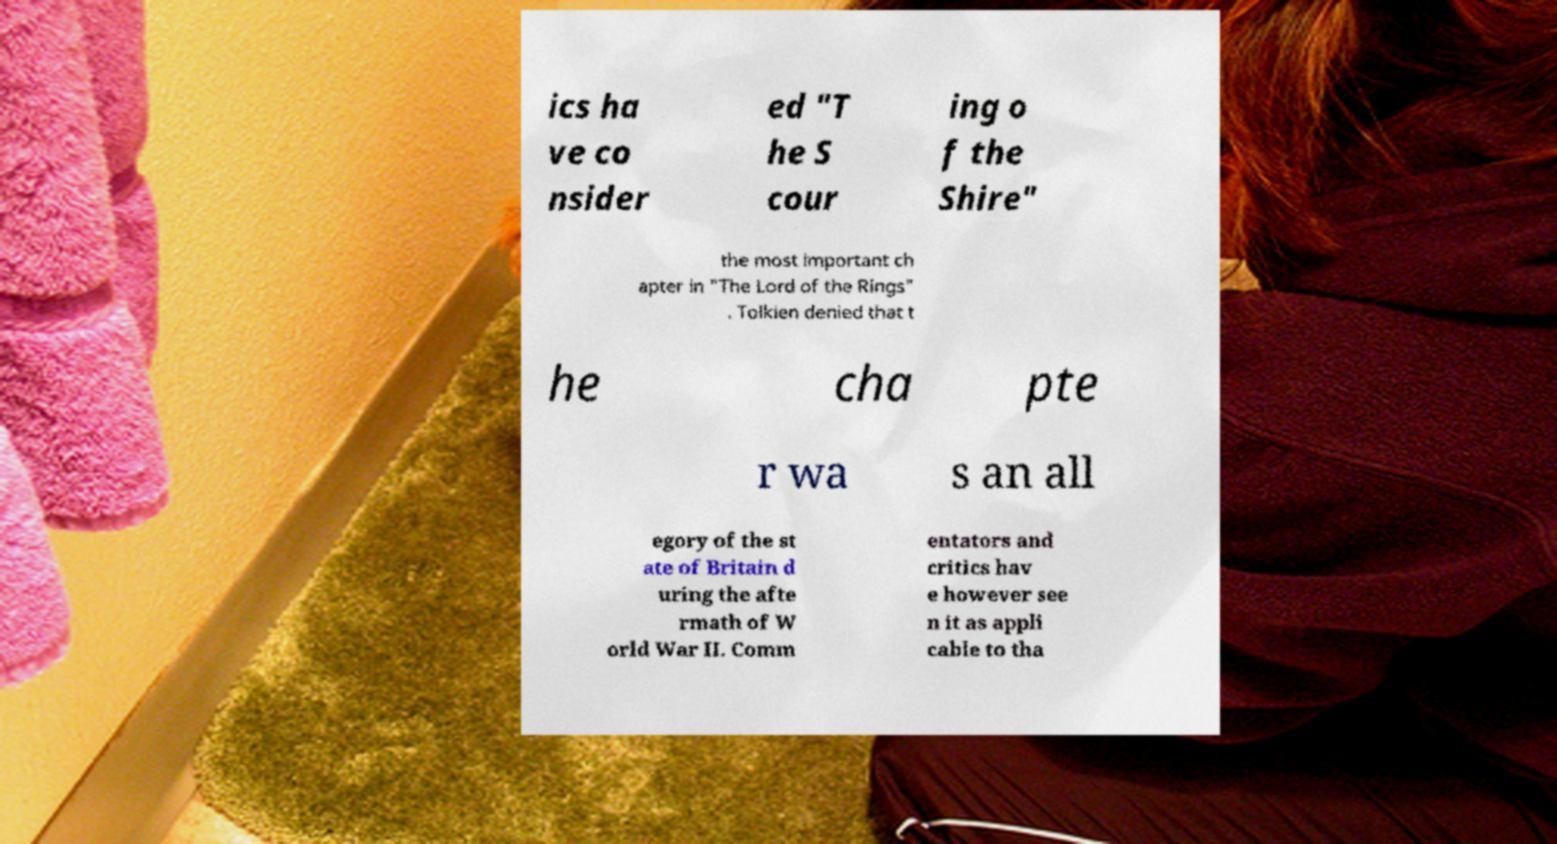There's text embedded in this image that I need extracted. Can you transcribe it verbatim? ics ha ve co nsider ed "T he S cour ing o f the Shire" the most important ch apter in "The Lord of the Rings" . Tolkien denied that t he cha pte r wa s an all egory of the st ate of Britain d uring the afte rmath of W orld War II. Comm entators and critics hav e however see n it as appli cable to tha 